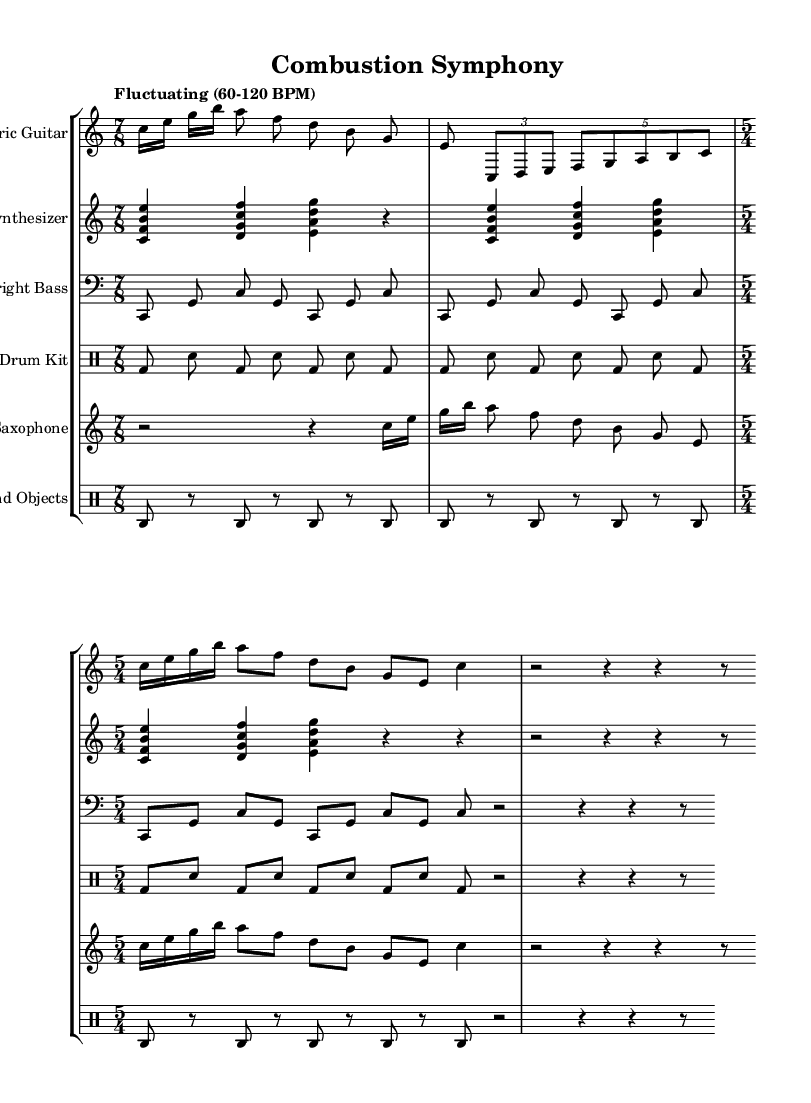What is the time signature of the first staff? The first staff has a time signature of 7/8, indicated at the beginning of the section.
Answer: 7/8 What is the tempo marking for the piece? The tempo marking "Fluctuating (60-120 BPM)" appears at the start of the first staff, indicating a flexible tempo.
Answer: Fluctuating (60-120 BPM) How many measures are there in the first staff? Counting the measures visually, there are six distinct measure separations shown in the first staff, representing the total number of measures.
Answer: 6 Which instrument plays in the bass clef? The Upright Bass staff is labeled with a bass clef, showing that this instrument plays notes in the bass clef range.
Answer: Upright Bass What type of rhythms are used in the drum kit section? The drum kit section features a repetitive pattern alternating between bass drum and snare drum, reflecting a structured rhythmic approach typical in fusion.
Answer: Alternating bass and snare How does the 'Found Objects' staff contribute to the texture of the piece? The 'Found Objects' staff adds percussive sounds that layer with the other instruments, enhancing the rhythmic foundation and creating an experimental texture.
Answer: Percussive layers What is the overall mood conveyed by the synthesizer's harmony? The synthesizer section uses chord clusters like <c' f' b' e''>, creating a rich, atmospheric quality that contributes to an experimental jazz fusion vibe.
Answer: Atmospheric quality 